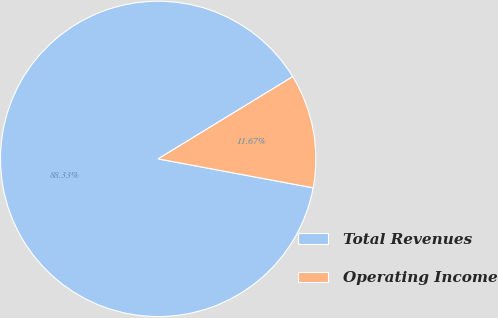Convert chart to OTSL. <chart><loc_0><loc_0><loc_500><loc_500><pie_chart><fcel>Total Revenues<fcel>Operating Income<nl><fcel>88.33%<fcel>11.67%<nl></chart> 